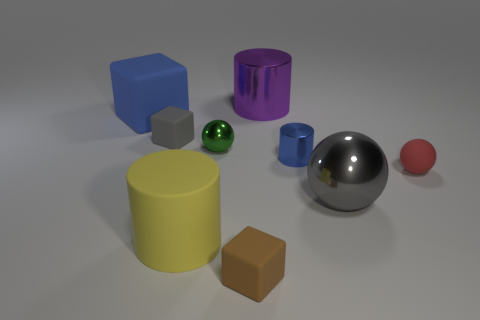Subtract all small balls. How many balls are left? 1 Add 1 tiny balls. How many objects exist? 10 Subtract all cubes. How many objects are left? 6 Subtract 2 spheres. How many spheres are left? 1 Subtract 0 yellow spheres. How many objects are left? 9 Subtract all brown blocks. Subtract all purple balls. How many blocks are left? 2 Subtract all matte cubes. Subtract all tiny brown matte objects. How many objects are left? 5 Add 6 purple shiny cylinders. How many purple shiny cylinders are left? 7 Add 7 blue rubber things. How many blue rubber things exist? 8 